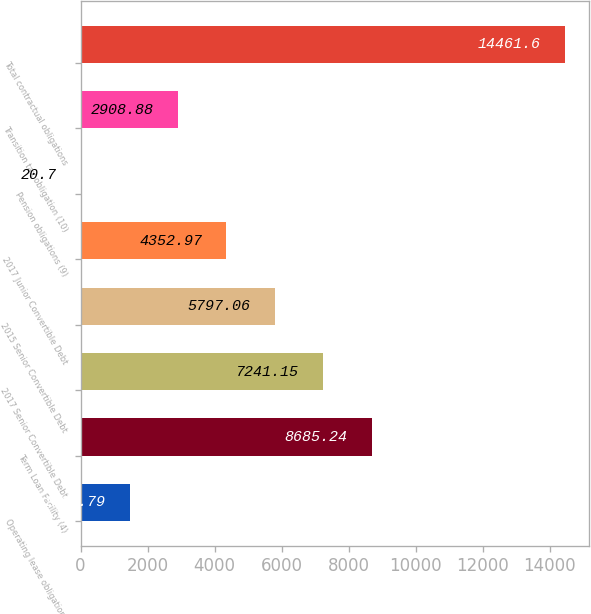Convert chart to OTSL. <chart><loc_0><loc_0><loc_500><loc_500><bar_chart><fcel>Operating lease obligations<fcel>Term Loan Facility (4)<fcel>2017 Senior Convertible Debt<fcel>2015 Senior Convertible Debt<fcel>2017 Junior Convertible Debt<fcel>Pension obligations (9)<fcel>Transition tax obligation (10)<fcel>Total contractual obligations<nl><fcel>1464.79<fcel>8685.24<fcel>7241.15<fcel>5797.06<fcel>4352.97<fcel>20.7<fcel>2908.88<fcel>14461.6<nl></chart> 